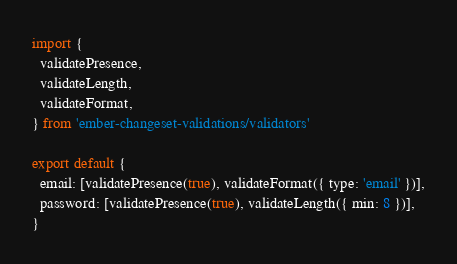<code> <loc_0><loc_0><loc_500><loc_500><_JavaScript_>import {
  validatePresence,
  validateLength,
  validateFormat,
} from 'ember-changeset-validations/validators'

export default {
  email: [validatePresence(true), validateFormat({ type: 'email' })],
  password: [validatePresence(true), validateLength({ min: 8 })],
}
</code> 